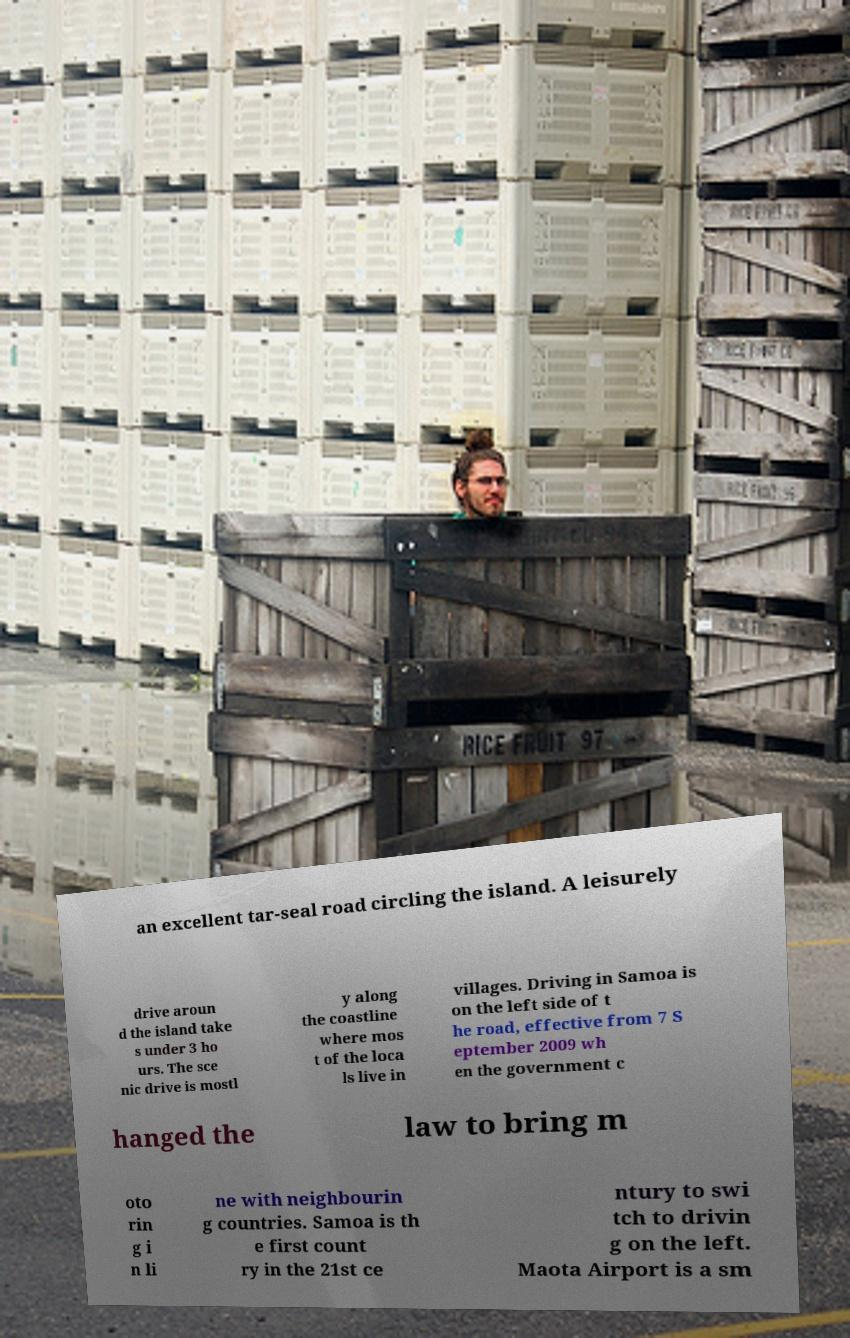What messages or text are displayed in this image? I need them in a readable, typed format. an excellent tar-seal road circling the island. A leisurely drive aroun d the island take s under 3 ho urs. The sce nic drive is mostl y along the coastline where mos t of the loca ls live in villages. Driving in Samoa is on the left side of t he road, effective from 7 S eptember 2009 wh en the government c hanged the law to bring m oto rin g i n li ne with neighbourin g countries. Samoa is th e first count ry in the 21st ce ntury to swi tch to drivin g on the left. Maota Airport is a sm 